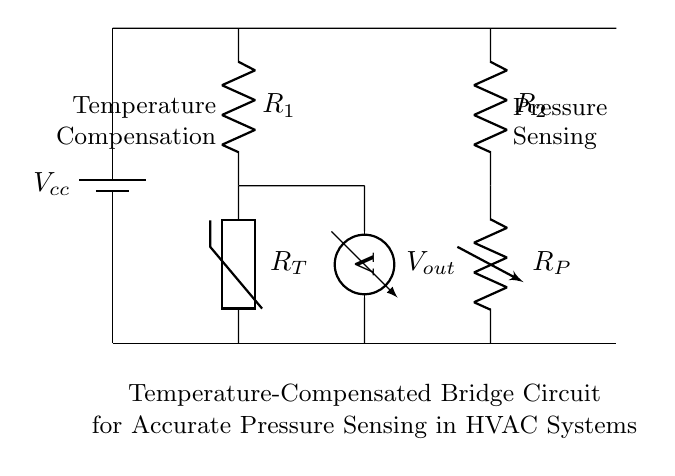What is the power supply voltage in this circuit? The circuit has a battery labeled Vcc, which typically represents the power supply voltage. In this case, the specific voltage is not provided in the visual, but generally, it is understood to be a standard voltage level in most applications.
Answer: Vcc What type of resistor is R1? R1 is labeled simply as a resistor without any special qualifications, so it can be inferred that it is a standard fixed resistor used for biasing or creating a reference in the circuit.
Answer: Fixed resistor What is the purpose of the thermistor in this bridge circuit? The thermistor, labeled R_T, is a temperature-sensitive resistor that changes resistance with temperature, thus enabling temperature compensation for the pressure sensing. This is crucial for maintaining accuracy in the measurements.
Answer: Temperature compensation Which components are used for pressure sensing in this circuit? The variable resistor R_P and the components surrounding it are part of the bridge configuration that allows for pressure changes to affect voltage output, thus enabling pressure sensing.
Answer: R_P How many resistors are present in the circuit? The circuit consists of three resistors: R1, R2, and R_P, which are all integral to the function of the thermal and pressure sensing mechanism.
Answer: Three What does V_out represent in this circuit? V_out is labeled as the output voltage of the bridge circuit, indicating the resultant voltage that reflects the pressure being sensed based on the balance and variations in resistance due to temperature changes.
Answer: Output voltage How does temperature affect the operation of this circuit? Temperature variations will alter the resistance of the thermistor R_T and potentially affect other resistive components, changing the voltage across the output (V_out) and allowing the circuit to calibrate for accurate pressure sensing in HVAC systems.
Answer: Affects resistance 